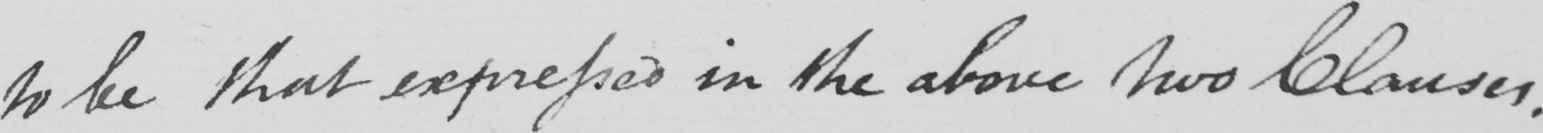Please provide the text content of this handwritten line. to be that expressed in the above two Clauses . 